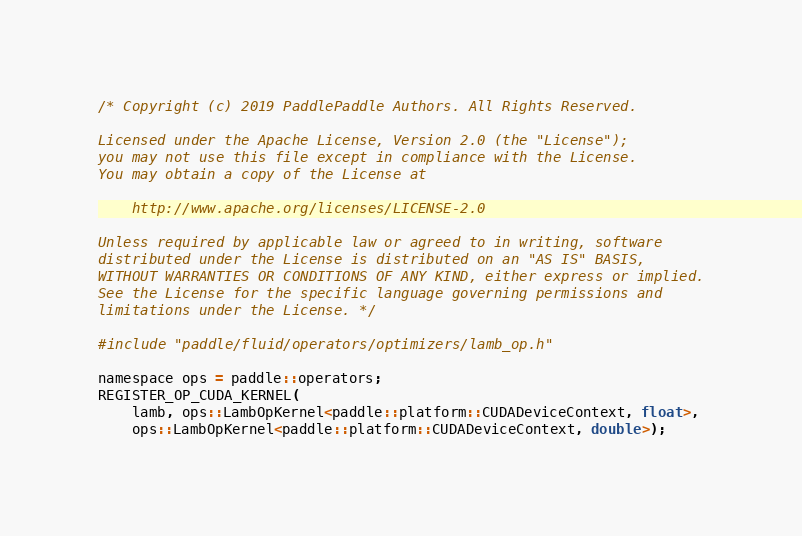<code> <loc_0><loc_0><loc_500><loc_500><_Cuda_>/* Copyright (c) 2019 PaddlePaddle Authors. All Rights Reserved.

Licensed under the Apache License, Version 2.0 (the "License");
you may not use this file except in compliance with the License.
You may obtain a copy of the License at

    http://www.apache.org/licenses/LICENSE-2.0

Unless required by applicable law or agreed to in writing, software
distributed under the License is distributed on an "AS IS" BASIS,
WITHOUT WARRANTIES OR CONDITIONS OF ANY KIND, either express or implied.
See the License for the specific language governing permissions and
limitations under the License. */

#include "paddle/fluid/operators/optimizers/lamb_op.h"

namespace ops = paddle::operators;
REGISTER_OP_CUDA_KERNEL(
    lamb, ops::LambOpKernel<paddle::platform::CUDADeviceContext, float>,
    ops::LambOpKernel<paddle::platform::CUDADeviceContext, double>);
</code> 